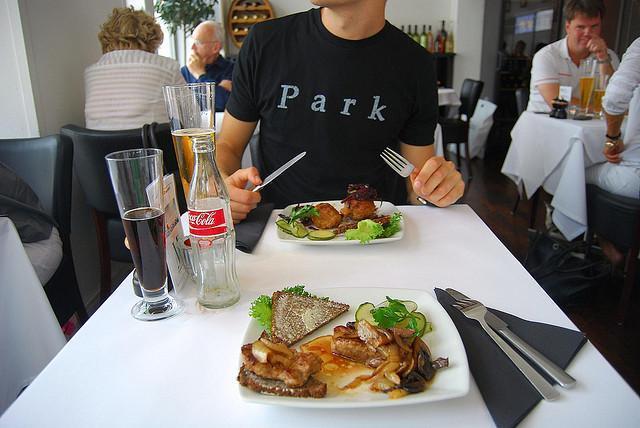How many chairs are there?
Give a very brief answer. 4. How many people are there?
Give a very brief answer. 6. How many sandwiches are visible?
Give a very brief answer. 1. How many cups are in the picture?
Give a very brief answer. 2. How many orange ropescables are attached to the clock?
Give a very brief answer. 0. 